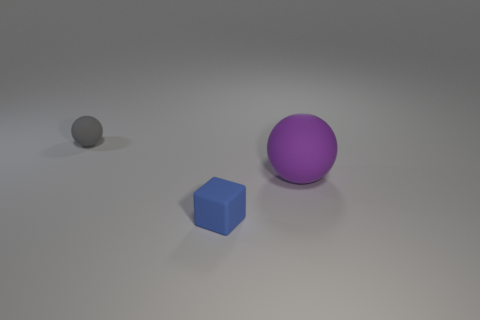Are there the same number of blue rubber things that are left of the small blue rubber object and large yellow metallic cubes?
Your response must be concise. Yes. Are there any rubber things that are left of the small matte thing that is behind the ball that is to the right of the tiny gray object?
Keep it short and to the point. No. What is the color of the large object that is the same material as the tiny blue cube?
Provide a succinct answer. Purple. There is a matte sphere that is behind the large object; is it the same color as the big object?
Make the answer very short. No. What number of spheres are either purple things or tiny blue metallic objects?
Give a very brief answer. 1. There is a sphere to the right of the matte sphere that is to the left of the thing that is on the right side of the tiny blue thing; what size is it?
Keep it short and to the point. Large. What is the shape of the gray object that is the same size as the matte cube?
Provide a succinct answer. Sphere. What shape is the small blue matte object?
Offer a very short reply. Cube. Is the material of the sphere in front of the small gray rubber ball the same as the small gray object?
Your response must be concise. Yes. How big is the matte sphere behind the purple sphere that is behind the small cube?
Offer a terse response. Small. 